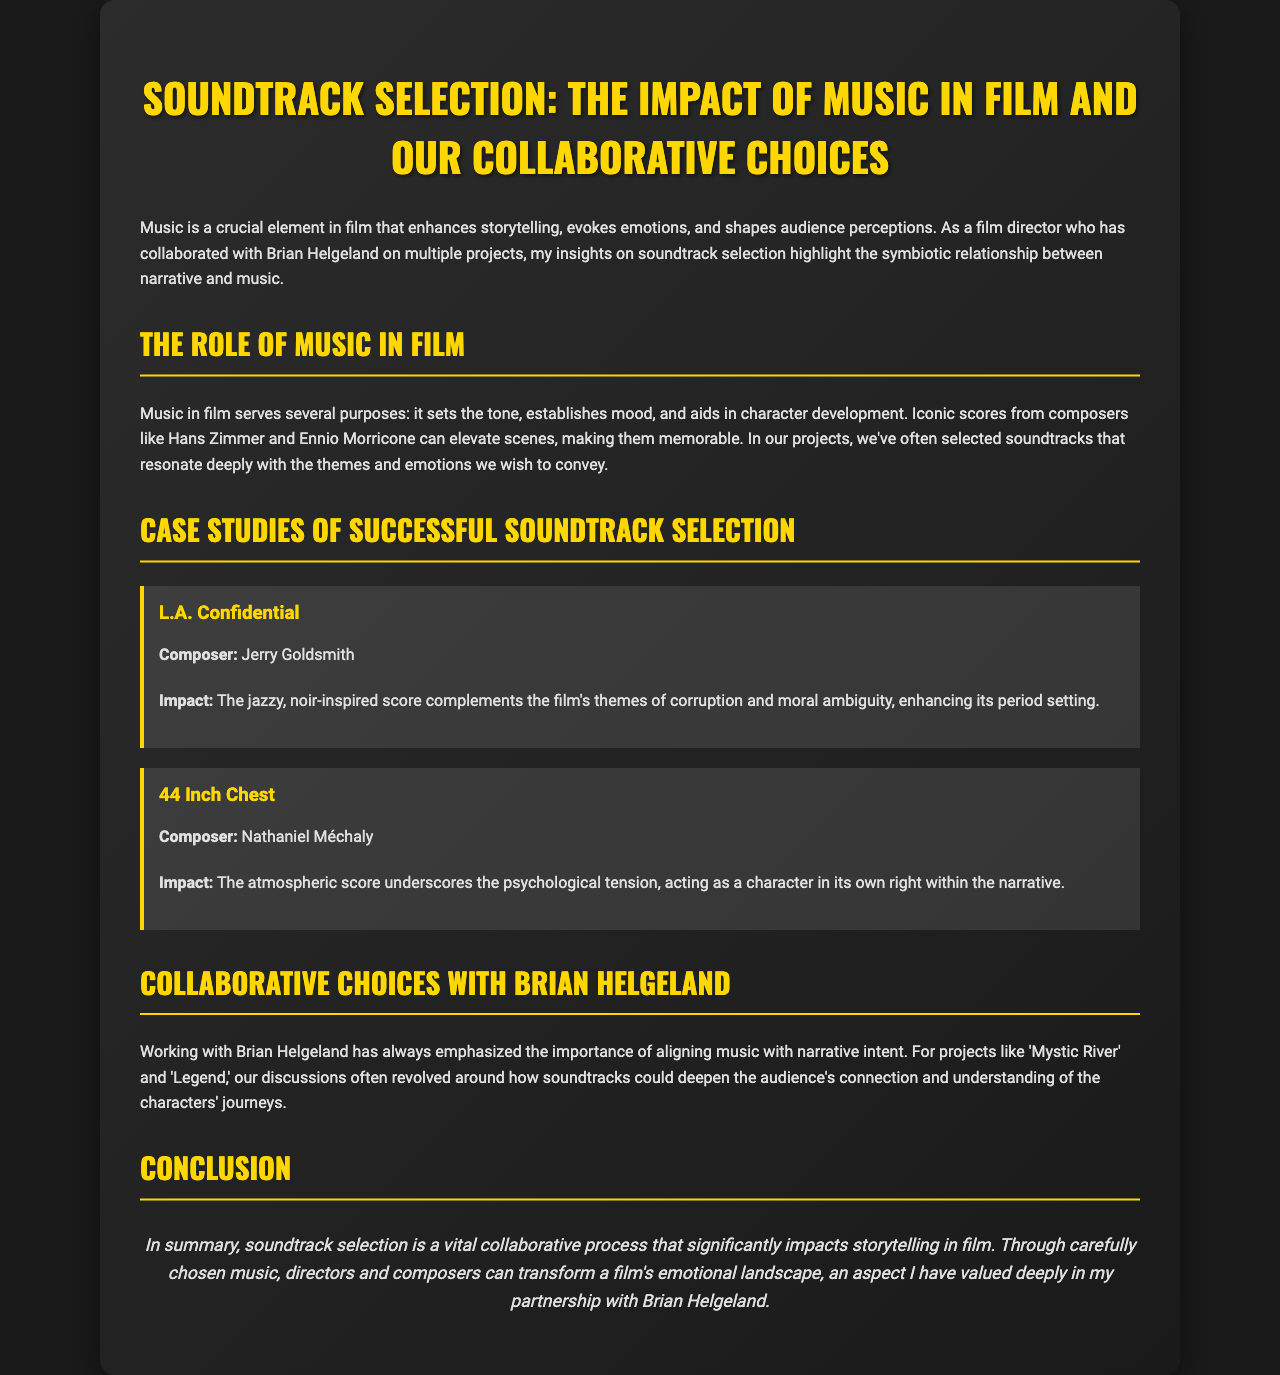What is the title of the brochure? The title of the brochure is prominently displayed at the top and summarizes the main topic.
Answer: Soundtrack Selection: The Impact of Music in Film and Our Collaborative Choices Who composed the score for L.A. Confidential? The brochure provides specific composer details for each case study, including the one for L.A. Confidential.
Answer: Jerry Goldsmith What film is associated with the score by Nathaniel Méchaly? The name of the film linked to Nathaniel Méchaly’s score is specified in the case study section.
Answer: 44 Inch Chest What aspect of filmmaking does the document emphasize? The emphasis on the role of music in film is a key focus throughout the document.
Answer: Storytelling In what projects did the author collaborate with Brian Helgeland? The document mentions specific films that highlight the author's collaborations with Brian Helgeland regarding music selection.
Answer: Mystic River and Legend What is the purpose of music in film according to the brochure? The document outlines the functions music serves in film, indicating its various roles.
Answer: Establishes mood What is highlighted as a crucial element in filmmaking? The text identifies this element and indicates its importance to the overall film-making process.
Answer: Music What is the impact of the score in 44 Inch Chest? The description of the score's effect within the narrative is discussed in the case study.
Answer: Psychological tension How does the author view the soundtrack selection process? The author provides a personal perspective on the importance of music collaboration with Brian Helgeland.
Answer: Vital collaborative process 